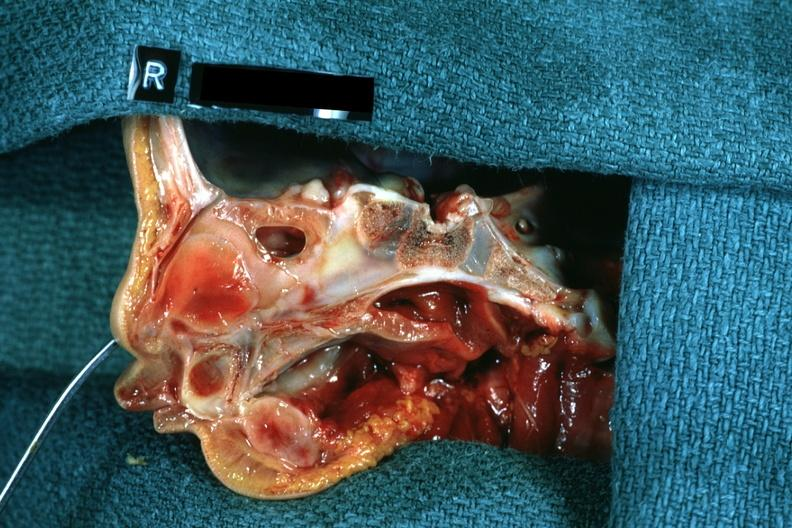what is right side atresia left?
Answer the question using a single word or phrase. Was patent hemisection of nose 